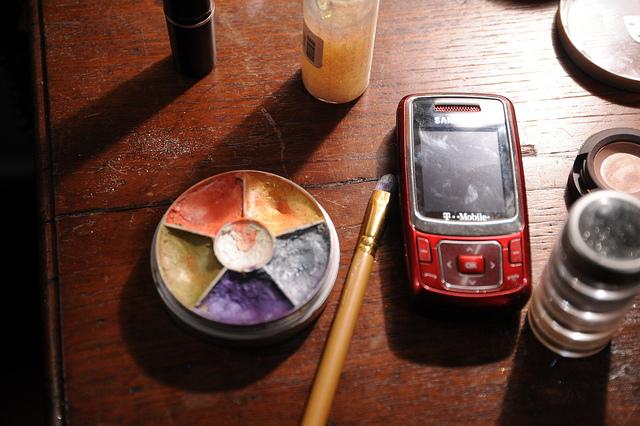What color is the cell phone?
Write a very short answer. Red. What brand of phone is it?
Give a very brief answer. Samsung. What is the phone laying on?
Write a very short answer. Table. 